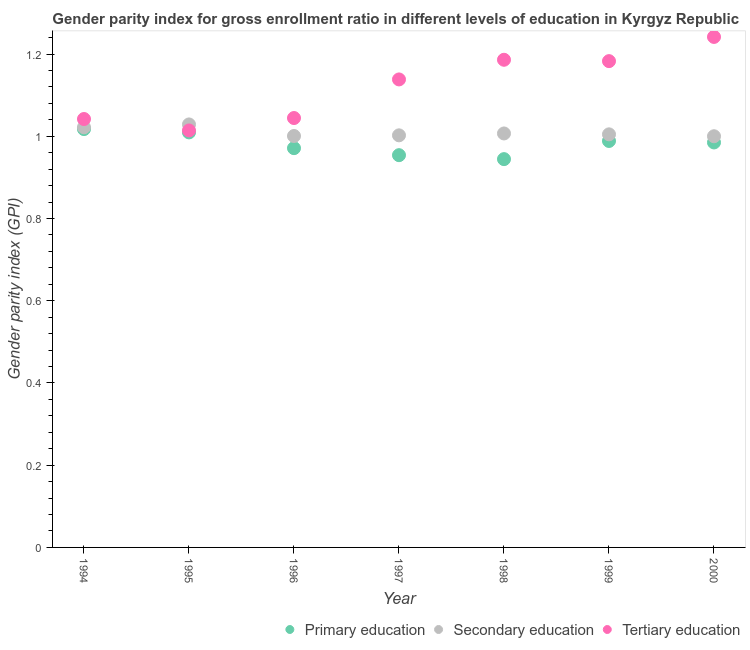How many different coloured dotlines are there?
Your response must be concise. 3. What is the gender parity index in secondary education in 2000?
Provide a succinct answer. 1. Across all years, what is the maximum gender parity index in secondary education?
Your response must be concise. 1.03. Across all years, what is the minimum gender parity index in tertiary education?
Your response must be concise. 1.01. What is the total gender parity index in secondary education in the graph?
Provide a short and direct response. 7.06. What is the difference between the gender parity index in secondary education in 1995 and that in 2000?
Ensure brevity in your answer.  0.03. What is the difference between the gender parity index in primary education in 1997 and the gender parity index in tertiary education in 1995?
Your answer should be very brief. -0.06. What is the average gender parity index in primary education per year?
Give a very brief answer. 0.98. In the year 1997, what is the difference between the gender parity index in primary education and gender parity index in secondary education?
Provide a short and direct response. -0.05. What is the ratio of the gender parity index in primary education in 1994 to that in 1996?
Keep it short and to the point. 1.05. Is the difference between the gender parity index in primary education in 1994 and 1995 greater than the difference between the gender parity index in secondary education in 1994 and 1995?
Your answer should be very brief. Yes. What is the difference between the highest and the second highest gender parity index in tertiary education?
Offer a very short reply. 0.06. What is the difference between the highest and the lowest gender parity index in primary education?
Ensure brevity in your answer.  0.07. In how many years, is the gender parity index in secondary education greater than the average gender parity index in secondary education taken over all years?
Provide a short and direct response. 2. Is the sum of the gender parity index in tertiary education in 1999 and 2000 greater than the maximum gender parity index in primary education across all years?
Your response must be concise. Yes. Is it the case that in every year, the sum of the gender parity index in primary education and gender parity index in secondary education is greater than the gender parity index in tertiary education?
Give a very brief answer. Yes. Is the gender parity index in primary education strictly less than the gender parity index in tertiary education over the years?
Make the answer very short. Yes. How many years are there in the graph?
Provide a short and direct response. 7. What is the difference between two consecutive major ticks on the Y-axis?
Ensure brevity in your answer.  0.2. Does the graph contain grids?
Ensure brevity in your answer.  No. Where does the legend appear in the graph?
Your answer should be compact. Bottom right. What is the title of the graph?
Make the answer very short. Gender parity index for gross enrollment ratio in different levels of education in Kyrgyz Republic. What is the label or title of the X-axis?
Give a very brief answer. Year. What is the label or title of the Y-axis?
Ensure brevity in your answer.  Gender parity index (GPI). What is the Gender parity index (GPI) of Primary education in 1994?
Your answer should be compact. 1.02. What is the Gender parity index (GPI) of Secondary education in 1994?
Ensure brevity in your answer.  1.02. What is the Gender parity index (GPI) in Tertiary education in 1994?
Your answer should be compact. 1.04. What is the Gender parity index (GPI) of Primary education in 1995?
Ensure brevity in your answer.  1.01. What is the Gender parity index (GPI) of Secondary education in 1995?
Ensure brevity in your answer.  1.03. What is the Gender parity index (GPI) of Tertiary education in 1995?
Provide a short and direct response. 1.01. What is the Gender parity index (GPI) in Primary education in 1996?
Offer a terse response. 0.97. What is the Gender parity index (GPI) in Secondary education in 1996?
Your response must be concise. 1. What is the Gender parity index (GPI) in Tertiary education in 1996?
Your response must be concise. 1.04. What is the Gender parity index (GPI) of Primary education in 1997?
Provide a short and direct response. 0.95. What is the Gender parity index (GPI) in Secondary education in 1997?
Your response must be concise. 1. What is the Gender parity index (GPI) of Tertiary education in 1997?
Offer a very short reply. 1.14. What is the Gender parity index (GPI) of Primary education in 1998?
Your response must be concise. 0.94. What is the Gender parity index (GPI) in Secondary education in 1998?
Your response must be concise. 1.01. What is the Gender parity index (GPI) of Tertiary education in 1998?
Provide a short and direct response. 1.19. What is the Gender parity index (GPI) of Primary education in 1999?
Provide a short and direct response. 0.99. What is the Gender parity index (GPI) in Secondary education in 1999?
Give a very brief answer. 1. What is the Gender parity index (GPI) of Tertiary education in 1999?
Your answer should be compact. 1.18. What is the Gender parity index (GPI) in Primary education in 2000?
Keep it short and to the point. 0.98. What is the Gender parity index (GPI) of Secondary education in 2000?
Provide a short and direct response. 1. What is the Gender parity index (GPI) of Tertiary education in 2000?
Your answer should be very brief. 1.24. Across all years, what is the maximum Gender parity index (GPI) of Primary education?
Your answer should be compact. 1.02. Across all years, what is the maximum Gender parity index (GPI) of Secondary education?
Provide a succinct answer. 1.03. Across all years, what is the maximum Gender parity index (GPI) in Tertiary education?
Provide a short and direct response. 1.24. Across all years, what is the minimum Gender parity index (GPI) of Primary education?
Give a very brief answer. 0.94. Across all years, what is the minimum Gender parity index (GPI) in Secondary education?
Provide a succinct answer. 1. Across all years, what is the minimum Gender parity index (GPI) of Tertiary education?
Keep it short and to the point. 1.01. What is the total Gender parity index (GPI) in Primary education in the graph?
Ensure brevity in your answer.  6.87. What is the total Gender parity index (GPI) of Secondary education in the graph?
Offer a very short reply. 7.07. What is the total Gender parity index (GPI) in Tertiary education in the graph?
Your answer should be very brief. 7.85. What is the difference between the Gender parity index (GPI) in Primary education in 1994 and that in 1995?
Provide a short and direct response. 0.01. What is the difference between the Gender parity index (GPI) of Secondary education in 1994 and that in 1995?
Your response must be concise. -0.01. What is the difference between the Gender parity index (GPI) in Tertiary education in 1994 and that in 1995?
Make the answer very short. 0.03. What is the difference between the Gender parity index (GPI) of Primary education in 1994 and that in 1996?
Make the answer very short. 0.05. What is the difference between the Gender parity index (GPI) of Secondary education in 1994 and that in 1996?
Give a very brief answer. 0.02. What is the difference between the Gender parity index (GPI) of Tertiary education in 1994 and that in 1996?
Offer a terse response. -0. What is the difference between the Gender parity index (GPI) in Primary education in 1994 and that in 1997?
Offer a very short reply. 0.06. What is the difference between the Gender parity index (GPI) of Secondary education in 1994 and that in 1997?
Your answer should be compact. 0.02. What is the difference between the Gender parity index (GPI) in Tertiary education in 1994 and that in 1997?
Provide a succinct answer. -0.1. What is the difference between the Gender parity index (GPI) of Primary education in 1994 and that in 1998?
Offer a terse response. 0.07. What is the difference between the Gender parity index (GPI) of Secondary education in 1994 and that in 1998?
Provide a succinct answer. 0.01. What is the difference between the Gender parity index (GPI) in Tertiary education in 1994 and that in 1998?
Provide a short and direct response. -0.14. What is the difference between the Gender parity index (GPI) in Primary education in 1994 and that in 1999?
Provide a short and direct response. 0.03. What is the difference between the Gender parity index (GPI) of Secondary education in 1994 and that in 1999?
Your answer should be compact. 0.02. What is the difference between the Gender parity index (GPI) of Tertiary education in 1994 and that in 1999?
Offer a very short reply. -0.14. What is the difference between the Gender parity index (GPI) in Primary education in 1994 and that in 2000?
Your response must be concise. 0.03. What is the difference between the Gender parity index (GPI) in Secondary education in 1994 and that in 2000?
Your response must be concise. 0.02. What is the difference between the Gender parity index (GPI) of Tertiary education in 1994 and that in 2000?
Make the answer very short. -0.2. What is the difference between the Gender parity index (GPI) of Primary education in 1995 and that in 1996?
Provide a short and direct response. 0.04. What is the difference between the Gender parity index (GPI) of Secondary education in 1995 and that in 1996?
Keep it short and to the point. 0.03. What is the difference between the Gender parity index (GPI) of Tertiary education in 1995 and that in 1996?
Offer a terse response. -0.03. What is the difference between the Gender parity index (GPI) of Primary education in 1995 and that in 1997?
Your answer should be very brief. 0.06. What is the difference between the Gender parity index (GPI) of Secondary education in 1995 and that in 1997?
Ensure brevity in your answer.  0.03. What is the difference between the Gender parity index (GPI) of Tertiary education in 1995 and that in 1997?
Keep it short and to the point. -0.12. What is the difference between the Gender parity index (GPI) of Primary education in 1995 and that in 1998?
Give a very brief answer. 0.07. What is the difference between the Gender parity index (GPI) of Secondary education in 1995 and that in 1998?
Your answer should be compact. 0.02. What is the difference between the Gender parity index (GPI) of Tertiary education in 1995 and that in 1998?
Offer a very short reply. -0.17. What is the difference between the Gender parity index (GPI) in Primary education in 1995 and that in 1999?
Provide a succinct answer. 0.02. What is the difference between the Gender parity index (GPI) in Secondary education in 1995 and that in 1999?
Your response must be concise. 0.02. What is the difference between the Gender parity index (GPI) of Tertiary education in 1995 and that in 1999?
Your answer should be compact. -0.17. What is the difference between the Gender parity index (GPI) in Primary education in 1995 and that in 2000?
Provide a succinct answer. 0.02. What is the difference between the Gender parity index (GPI) of Secondary education in 1995 and that in 2000?
Provide a short and direct response. 0.03. What is the difference between the Gender parity index (GPI) of Tertiary education in 1995 and that in 2000?
Make the answer very short. -0.23. What is the difference between the Gender parity index (GPI) of Primary education in 1996 and that in 1997?
Ensure brevity in your answer.  0.02. What is the difference between the Gender parity index (GPI) in Secondary education in 1996 and that in 1997?
Keep it short and to the point. -0. What is the difference between the Gender parity index (GPI) in Tertiary education in 1996 and that in 1997?
Offer a terse response. -0.09. What is the difference between the Gender parity index (GPI) in Primary education in 1996 and that in 1998?
Provide a succinct answer. 0.03. What is the difference between the Gender parity index (GPI) in Secondary education in 1996 and that in 1998?
Provide a short and direct response. -0.01. What is the difference between the Gender parity index (GPI) in Tertiary education in 1996 and that in 1998?
Your answer should be compact. -0.14. What is the difference between the Gender parity index (GPI) of Primary education in 1996 and that in 1999?
Keep it short and to the point. -0.02. What is the difference between the Gender parity index (GPI) of Secondary education in 1996 and that in 1999?
Give a very brief answer. -0. What is the difference between the Gender parity index (GPI) in Tertiary education in 1996 and that in 1999?
Keep it short and to the point. -0.14. What is the difference between the Gender parity index (GPI) in Primary education in 1996 and that in 2000?
Give a very brief answer. -0.01. What is the difference between the Gender parity index (GPI) of Secondary education in 1996 and that in 2000?
Your answer should be very brief. 0. What is the difference between the Gender parity index (GPI) in Tertiary education in 1996 and that in 2000?
Make the answer very short. -0.2. What is the difference between the Gender parity index (GPI) of Primary education in 1997 and that in 1998?
Provide a succinct answer. 0.01. What is the difference between the Gender parity index (GPI) of Secondary education in 1997 and that in 1998?
Your answer should be compact. -0. What is the difference between the Gender parity index (GPI) in Tertiary education in 1997 and that in 1998?
Make the answer very short. -0.05. What is the difference between the Gender parity index (GPI) of Primary education in 1997 and that in 1999?
Your answer should be compact. -0.03. What is the difference between the Gender parity index (GPI) in Secondary education in 1997 and that in 1999?
Offer a very short reply. -0. What is the difference between the Gender parity index (GPI) in Tertiary education in 1997 and that in 1999?
Offer a terse response. -0.04. What is the difference between the Gender parity index (GPI) of Primary education in 1997 and that in 2000?
Your response must be concise. -0.03. What is the difference between the Gender parity index (GPI) of Secondary education in 1997 and that in 2000?
Make the answer very short. 0. What is the difference between the Gender parity index (GPI) of Tertiary education in 1997 and that in 2000?
Offer a terse response. -0.1. What is the difference between the Gender parity index (GPI) in Primary education in 1998 and that in 1999?
Ensure brevity in your answer.  -0.04. What is the difference between the Gender parity index (GPI) in Secondary education in 1998 and that in 1999?
Provide a succinct answer. 0. What is the difference between the Gender parity index (GPI) of Tertiary education in 1998 and that in 1999?
Provide a succinct answer. 0. What is the difference between the Gender parity index (GPI) of Primary education in 1998 and that in 2000?
Keep it short and to the point. -0.04. What is the difference between the Gender parity index (GPI) of Secondary education in 1998 and that in 2000?
Your response must be concise. 0.01. What is the difference between the Gender parity index (GPI) in Tertiary education in 1998 and that in 2000?
Keep it short and to the point. -0.06. What is the difference between the Gender parity index (GPI) in Primary education in 1999 and that in 2000?
Provide a short and direct response. 0. What is the difference between the Gender parity index (GPI) of Secondary education in 1999 and that in 2000?
Your response must be concise. 0. What is the difference between the Gender parity index (GPI) in Tertiary education in 1999 and that in 2000?
Your response must be concise. -0.06. What is the difference between the Gender parity index (GPI) of Primary education in 1994 and the Gender parity index (GPI) of Secondary education in 1995?
Give a very brief answer. -0.01. What is the difference between the Gender parity index (GPI) in Primary education in 1994 and the Gender parity index (GPI) in Tertiary education in 1995?
Make the answer very short. 0. What is the difference between the Gender parity index (GPI) of Secondary education in 1994 and the Gender parity index (GPI) of Tertiary education in 1995?
Give a very brief answer. 0.01. What is the difference between the Gender parity index (GPI) in Primary education in 1994 and the Gender parity index (GPI) in Secondary education in 1996?
Provide a short and direct response. 0.02. What is the difference between the Gender parity index (GPI) in Primary education in 1994 and the Gender parity index (GPI) in Tertiary education in 1996?
Your response must be concise. -0.03. What is the difference between the Gender parity index (GPI) in Secondary education in 1994 and the Gender parity index (GPI) in Tertiary education in 1996?
Your answer should be very brief. -0.02. What is the difference between the Gender parity index (GPI) in Primary education in 1994 and the Gender parity index (GPI) in Secondary education in 1997?
Offer a very short reply. 0.02. What is the difference between the Gender parity index (GPI) of Primary education in 1994 and the Gender parity index (GPI) of Tertiary education in 1997?
Your answer should be compact. -0.12. What is the difference between the Gender parity index (GPI) in Secondary education in 1994 and the Gender parity index (GPI) in Tertiary education in 1997?
Offer a very short reply. -0.12. What is the difference between the Gender parity index (GPI) in Primary education in 1994 and the Gender parity index (GPI) in Secondary education in 1998?
Make the answer very short. 0.01. What is the difference between the Gender parity index (GPI) in Primary education in 1994 and the Gender parity index (GPI) in Tertiary education in 1998?
Give a very brief answer. -0.17. What is the difference between the Gender parity index (GPI) of Secondary education in 1994 and the Gender parity index (GPI) of Tertiary education in 1998?
Ensure brevity in your answer.  -0.16. What is the difference between the Gender parity index (GPI) of Primary education in 1994 and the Gender parity index (GPI) of Secondary education in 1999?
Your answer should be compact. 0.01. What is the difference between the Gender parity index (GPI) in Primary education in 1994 and the Gender parity index (GPI) in Tertiary education in 1999?
Make the answer very short. -0.17. What is the difference between the Gender parity index (GPI) of Secondary education in 1994 and the Gender parity index (GPI) of Tertiary education in 1999?
Provide a succinct answer. -0.16. What is the difference between the Gender parity index (GPI) of Primary education in 1994 and the Gender parity index (GPI) of Secondary education in 2000?
Offer a very short reply. 0.02. What is the difference between the Gender parity index (GPI) of Primary education in 1994 and the Gender parity index (GPI) of Tertiary education in 2000?
Provide a short and direct response. -0.22. What is the difference between the Gender parity index (GPI) of Secondary education in 1994 and the Gender parity index (GPI) of Tertiary education in 2000?
Provide a short and direct response. -0.22. What is the difference between the Gender parity index (GPI) of Primary education in 1995 and the Gender parity index (GPI) of Secondary education in 1996?
Your answer should be compact. 0.01. What is the difference between the Gender parity index (GPI) in Primary education in 1995 and the Gender parity index (GPI) in Tertiary education in 1996?
Make the answer very short. -0.03. What is the difference between the Gender parity index (GPI) in Secondary education in 1995 and the Gender parity index (GPI) in Tertiary education in 1996?
Offer a very short reply. -0.02. What is the difference between the Gender parity index (GPI) in Primary education in 1995 and the Gender parity index (GPI) in Secondary education in 1997?
Your response must be concise. 0.01. What is the difference between the Gender parity index (GPI) of Primary education in 1995 and the Gender parity index (GPI) of Tertiary education in 1997?
Offer a very short reply. -0.13. What is the difference between the Gender parity index (GPI) of Secondary education in 1995 and the Gender parity index (GPI) of Tertiary education in 1997?
Make the answer very short. -0.11. What is the difference between the Gender parity index (GPI) in Primary education in 1995 and the Gender parity index (GPI) in Secondary education in 1998?
Provide a succinct answer. 0. What is the difference between the Gender parity index (GPI) of Primary education in 1995 and the Gender parity index (GPI) of Tertiary education in 1998?
Offer a very short reply. -0.18. What is the difference between the Gender parity index (GPI) in Secondary education in 1995 and the Gender parity index (GPI) in Tertiary education in 1998?
Your answer should be compact. -0.16. What is the difference between the Gender parity index (GPI) of Primary education in 1995 and the Gender parity index (GPI) of Secondary education in 1999?
Give a very brief answer. 0. What is the difference between the Gender parity index (GPI) of Primary education in 1995 and the Gender parity index (GPI) of Tertiary education in 1999?
Ensure brevity in your answer.  -0.17. What is the difference between the Gender parity index (GPI) in Secondary education in 1995 and the Gender parity index (GPI) in Tertiary education in 1999?
Your response must be concise. -0.15. What is the difference between the Gender parity index (GPI) in Primary education in 1995 and the Gender parity index (GPI) in Secondary education in 2000?
Provide a succinct answer. 0.01. What is the difference between the Gender parity index (GPI) of Primary education in 1995 and the Gender parity index (GPI) of Tertiary education in 2000?
Offer a very short reply. -0.23. What is the difference between the Gender parity index (GPI) in Secondary education in 1995 and the Gender parity index (GPI) in Tertiary education in 2000?
Your answer should be very brief. -0.21. What is the difference between the Gender parity index (GPI) in Primary education in 1996 and the Gender parity index (GPI) in Secondary education in 1997?
Keep it short and to the point. -0.03. What is the difference between the Gender parity index (GPI) of Primary education in 1996 and the Gender parity index (GPI) of Tertiary education in 1997?
Give a very brief answer. -0.17. What is the difference between the Gender parity index (GPI) of Secondary education in 1996 and the Gender parity index (GPI) of Tertiary education in 1997?
Your answer should be compact. -0.14. What is the difference between the Gender parity index (GPI) in Primary education in 1996 and the Gender parity index (GPI) in Secondary education in 1998?
Your answer should be compact. -0.04. What is the difference between the Gender parity index (GPI) in Primary education in 1996 and the Gender parity index (GPI) in Tertiary education in 1998?
Give a very brief answer. -0.21. What is the difference between the Gender parity index (GPI) of Secondary education in 1996 and the Gender parity index (GPI) of Tertiary education in 1998?
Make the answer very short. -0.19. What is the difference between the Gender parity index (GPI) in Primary education in 1996 and the Gender parity index (GPI) in Secondary education in 1999?
Keep it short and to the point. -0.03. What is the difference between the Gender parity index (GPI) in Primary education in 1996 and the Gender parity index (GPI) in Tertiary education in 1999?
Keep it short and to the point. -0.21. What is the difference between the Gender parity index (GPI) in Secondary education in 1996 and the Gender parity index (GPI) in Tertiary education in 1999?
Your response must be concise. -0.18. What is the difference between the Gender parity index (GPI) of Primary education in 1996 and the Gender parity index (GPI) of Secondary education in 2000?
Your answer should be compact. -0.03. What is the difference between the Gender parity index (GPI) of Primary education in 1996 and the Gender parity index (GPI) of Tertiary education in 2000?
Give a very brief answer. -0.27. What is the difference between the Gender parity index (GPI) in Secondary education in 1996 and the Gender parity index (GPI) in Tertiary education in 2000?
Your answer should be compact. -0.24. What is the difference between the Gender parity index (GPI) in Primary education in 1997 and the Gender parity index (GPI) in Secondary education in 1998?
Your answer should be very brief. -0.05. What is the difference between the Gender parity index (GPI) in Primary education in 1997 and the Gender parity index (GPI) in Tertiary education in 1998?
Offer a very short reply. -0.23. What is the difference between the Gender parity index (GPI) of Secondary education in 1997 and the Gender parity index (GPI) of Tertiary education in 1998?
Give a very brief answer. -0.18. What is the difference between the Gender parity index (GPI) in Primary education in 1997 and the Gender parity index (GPI) in Secondary education in 1999?
Provide a succinct answer. -0.05. What is the difference between the Gender parity index (GPI) in Primary education in 1997 and the Gender parity index (GPI) in Tertiary education in 1999?
Your answer should be compact. -0.23. What is the difference between the Gender parity index (GPI) of Secondary education in 1997 and the Gender parity index (GPI) of Tertiary education in 1999?
Offer a very short reply. -0.18. What is the difference between the Gender parity index (GPI) in Primary education in 1997 and the Gender parity index (GPI) in Secondary education in 2000?
Ensure brevity in your answer.  -0.05. What is the difference between the Gender parity index (GPI) of Primary education in 1997 and the Gender parity index (GPI) of Tertiary education in 2000?
Provide a short and direct response. -0.29. What is the difference between the Gender parity index (GPI) of Secondary education in 1997 and the Gender parity index (GPI) of Tertiary education in 2000?
Ensure brevity in your answer.  -0.24. What is the difference between the Gender parity index (GPI) of Primary education in 1998 and the Gender parity index (GPI) of Secondary education in 1999?
Make the answer very short. -0.06. What is the difference between the Gender parity index (GPI) in Primary education in 1998 and the Gender parity index (GPI) in Tertiary education in 1999?
Your answer should be compact. -0.24. What is the difference between the Gender parity index (GPI) in Secondary education in 1998 and the Gender parity index (GPI) in Tertiary education in 1999?
Make the answer very short. -0.18. What is the difference between the Gender parity index (GPI) of Primary education in 1998 and the Gender parity index (GPI) of Secondary education in 2000?
Provide a short and direct response. -0.06. What is the difference between the Gender parity index (GPI) in Primary education in 1998 and the Gender parity index (GPI) in Tertiary education in 2000?
Offer a terse response. -0.3. What is the difference between the Gender parity index (GPI) in Secondary education in 1998 and the Gender parity index (GPI) in Tertiary education in 2000?
Your answer should be very brief. -0.23. What is the difference between the Gender parity index (GPI) in Primary education in 1999 and the Gender parity index (GPI) in Secondary education in 2000?
Provide a short and direct response. -0.01. What is the difference between the Gender parity index (GPI) of Primary education in 1999 and the Gender parity index (GPI) of Tertiary education in 2000?
Ensure brevity in your answer.  -0.25. What is the difference between the Gender parity index (GPI) of Secondary education in 1999 and the Gender parity index (GPI) of Tertiary education in 2000?
Provide a succinct answer. -0.24. What is the average Gender parity index (GPI) of Primary education per year?
Offer a very short reply. 0.98. What is the average Gender parity index (GPI) of Secondary education per year?
Offer a terse response. 1.01. What is the average Gender parity index (GPI) in Tertiary education per year?
Give a very brief answer. 1.12. In the year 1994, what is the difference between the Gender parity index (GPI) in Primary education and Gender parity index (GPI) in Secondary education?
Your answer should be very brief. -0. In the year 1994, what is the difference between the Gender parity index (GPI) of Primary education and Gender parity index (GPI) of Tertiary education?
Your answer should be compact. -0.02. In the year 1994, what is the difference between the Gender parity index (GPI) in Secondary education and Gender parity index (GPI) in Tertiary education?
Provide a short and direct response. -0.02. In the year 1995, what is the difference between the Gender parity index (GPI) of Primary education and Gender parity index (GPI) of Secondary education?
Provide a succinct answer. -0.02. In the year 1995, what is the difference between the Gender parity index (GPI) in Primary education and Gender parity index (GPI) in Tertiary education?
Your answer should be very brief. -0. In the year 1995, what is the difference between the Gender parity index (GPI) of Secondary education and Gender parity index (GPI) of Tertiary education?
Ensure brevity in your answer.  0.01. In the year 1996, what is the difference between the Gender parity index (GPI) of Primary education and Gender parity index (GPI) of Secondary education?
Your response must be concise. -0.03. In the year 1996, what is the difference between the Gender parity index (GPI) in Primary education and Gender parity index (GPI) in Tertiary education?
Your response must be concise. -0.07. In the year 1996, what is the difference between the Gender parity index (GPI) in Secondary education and Gender parity index (GPI) in Tertiary education?
Your answer should be very brief. -0.04. In the year 1997, what is the difference between the Gender parity index (GPI) of Primary education and Gender parity index (GPI) of Secondary education?
Provide a succinct answer. -0.05. In the year 1997, what is the difference between the Gender parity index (GPI) in Primary education and Gender parity index (GPI) in Tertiary education?
Give a very brief answer. -0.18. In the year 1997, what is the difference between the Gender parity index (GPI) of Secondary education and Gender parity index (GPI) of Tertiary education?
Offer a very short reply. -0.14. In the year 1998, what is the difference between the Gender parity index (GPI) of Primary education and Gender parity index (GPI) of Secondary education?
Your answer should be compact. -0.06. In the year 1998, what is the difference between the Gender parity index (GPI) of Primary education and Gender parity index (GPI) of Tertiary education?
Provide a succinct answer. -0.24. In the year 1998, what is the difference between the Gender parity index (GPI) in Secondary education and Gender parity index (GPI) in Tertiary education?
Make the answer very short. -0.18. In the year 1999, what is the difference between the Gender parity index (GPI) of Primary education and Gender parity index (GPI) of Secondary education?
Provide a short and direct response. -0.02. In the year 1999, what is the difference between the Gender parity index (GPI) of Primary education and Gender parity index (GPI) of Tertiary education?
Offer a terse response. -0.19. In the year 1999, what is the difference between the Gender parity index (GPI) in Secondary education and Gender parity index (GPI) in Tertiary education?
Provide a succinct answer. -0.18. In the year 2000, what is the difference between the Gender parity index (GPI) of Primary education and Gender parity index (GPI) of Secondary education?
Make the answer very short. -0.02. In the year 2000, what is the difference between the Gender parity index (GPI) in Primary education and Gender parity index (GPI) in Tertiary education?
Offer a very short reply. -0.26. In the year 2000, what is the difference between the Gender parity index (GPI) of Secondary education and Gender parity index (GPI) of Tertiary education?
Your answer should be compact. -0.24. What is the ratio of the Gender parity index (GPI) in Primary education in 1994 to that in 1995?
Ensure brevity in your answer.  1.01. What is the ratio of the Gender parity index (GPI) in Tertiary education in 1994 to that in 1995?
Give a very brief answer. 1.03. What is the ratio of the Gender parity index (GPI) in Primary education in 1994 to that in 1996?
Provide a succinct answer. 1.05. What is the ratio of the Gender parity index (GPI) of Secondary education in 1994 to that in 1996?
Your answer should be compact. 1.02. What is the ratio of the Gender parity index (GPI) of Tertiary education in 1994 to that in 1996?
Offer a terse response. 1. What is the ratio of the Gender parity index (GPI) of Primary education in 1994 to that in 1997?
Your response must be concise. 1.07. What is the ratio of the Gender parity index (GPI) of Secondary education in 1994 to that in 1997?
Offer a terse response. 1.02. What is the ratio of the Gender parity index (GPI) of Tertiary education in 1994 to that in 1997?
Your response must be concise. 0.92. What is the ratio of the Gender parity index (GPI) in Primary education in 1994 to that in 1998?
Make the answer very short. 1.08. What is the ratio of the Gender parity index (GPI) of Secondary education in 1994 to that in 1998?
Provide a short and direct response. 1.01. What is the ratio of the Gender parity index (GPI) in Tertiary education in 1994 to that in 1998?
Keep it short and to the point. 0.88. What is the ratio of the Gender parity index (GPI) of Primary education in 1994 to that in 1999?
Ensure brevity in your answer.  1.03. What is the ratio of the Gender parity index (GPI) of Secondary education in 1994 to that in 1999?
Your answer should be very brief. 1.02. What is the ratio of the Gender parity index (GPI) in Tertiary education in 1994 to that in 1999?
Your answer should be compact. 0.88. What is the ratio of the Gender parity index (GPI) in Primary education in 1994 to that in 2000?
Provide a succinct answer. 1.03. What is the ratio of the Gender parity index (GPI) in Secondary education in 1994 to that in 2000?
Your answer should be very brief. 1.02. What is the ratio of the Gender parity index (GPI) of Tertiary education in 1994 to that in 2000?
Offer a terse response. 0.84. What is the ratio of the Gender parity index (GPI) of Primary education in 1995 to that in 1996?
Ensure brevity in your answer.  1.04. What is the ratio of the Gender parity index (GPI) in Secondary education in 1995 to that in 1996?
Offer a terse response. 1.03. What is the ratio of the Gender parity index (GPI) in Tertiary education in 1995 to that in 1996?
Keep it short and to the point. 0.97. What is the ratio of the Gender parity index (GPI) in Primary education in 1995 to that in 1997?
Ensure brevity in your answer.  1.06. What is the ratio of the Gender parity index (GPI) in Secondary education in 1995 to that in 1997?
Offer a terse response. 1.03. What is the ratio of the Gender parity index (GPI) in Tertiary education in 1995 to that in 1997?
Ensure brevity in your answer.  0.89. What is the ratio of the Gender parity index (GPI) in Primary education in 1995 to that in 1998?
Keep it short and to the point. 1.07. What is the ratio of the Gender parity index (GPI) in Secondary education in 1995 to that in 1998?
Provide a short and direct response. 1.02. What is the ratio of the Gender parity index (GPI) of Tertiary education in 1995 to that in 1998?
Your answer should be very brief. 0.86. What is the ratio of the Gender parity index (GPI) of Primary education in 1995 to that in 1999?
Give a very brief answer. 1.02. What is the ratio of the Gender parity index (GPI) in Tertiary education in 1995 to that in 1999?
Offer a terse response. 0.86. What is the ratio of the Gender parity index (GPI) in Primary education in 1995 to that in 2000?
Ensure brevity in your answer.  1.02. What is the ratio of the Gender parity index (GPI) of Secondary education in 1995 to that in 2000?
Give a very brief answer. 1.03. What is the ratio of the Gender parity index (GPI) of Tertiary education in 1995 to that in 2000?
Your response must be concise. 0.82. What is the ratio of the Gender parity index (GPI) of Primary education in 1996 to that in 1997?
Ensure brevity in your answer.  1.02. What is the ratio of the Gender parity index (GPI) in Tertiary education in 1996 to that in 1997?
Provide a succinct answer. 0.92. What is the ratio of the Gender parity index (GPI) of Primary education in 1996 to that in 1998?
Give a very brief answer. 1.03. What is the ratio of the Gender parity index (GPI) in Tertiary education in 1996 to that in 1998?
Offer a very short reply. 0.88. What is the ratio of the Gender parity index (GPI) in Primary education in 1996 to that in 1999?
Offer a very short reply. 0.98. What is the ratio of the Gender parity index (GPI) in Tertiary education in 1996 to that in 1999?
Ensure brevity in your answer.  0.88. What is the ratio of the Gender parity index (GPI) of Primary education in 1996 to that in 2000?
Keep it short and to the point. 0.99. What is the ratio of the Gender parity index (GPI) in Tertiary education in 1996 to that in 2000?
Ensure brevity in your answer.  0.84. What is the ratio of the Gender parity index (GPI) of Primary education in 1997 to that in 1998?
Provide a succinct answer. 1.01. What is the ratio of the Gender parity index (GPI) of Secondary education in 1997 to that in 1998?
Offer a very short reply. 1. What is the ratio of the Gender parity index (GPI) of Tertiary education in 1997 to that in 1998?
Offer a very short reply. 0.96. What is the ratio of the Gender parity index (GPI) of Primary education in 1997 to that in 1999?
Your response must be concise. 0.96. What is the ratio of the Gender parity index (GPI) in Secondary education in 1997 to that in 1999?
Keep it short and to the point. 1. What is the ratio of the Gender parity index (GPI) of Tertiary education in 1997 to that in 1999?
Offer a terse response. 0.96. What is the ratio of the Gender parity index (GPI) of Primary education in 1997 to that in 2000?
Ensure brevity in your answer.  0.97. What is the ratio of the Gender parity index (GPI) of Tertiary education in 1997 to that in 2000?
Offer a terse response. 0.92. What is the ratio of the Gender parity index (GPI) in Primary education in 1998 to that in 1999?
Your response must be concise. 0.96. What is the ratio of the Gender parity index (GPI) in Secondary education in 1998 to that in 1999?
Keep it short and to the point. 1. What is the ratio of the Gender parity index (GPI) of Tertiary education in 1998 to that in 1999?
Provide a short and direct response. 1. What is the ratio of the Gender parity index (GPI) of Primary education in 1998 to that in 2000?
Your answer should be compact. 0.96. What is the ratio of the Gender parity index (GPI) in Secondary education in 1998 to that in 2000?
Offer a very short reply. 1.01. What is the ratio of the Gender parity index (GPI) in Tertiary education in 1998 to that in 2000?
Offer a terse response. 0.96. What is the ratio of the Gender parity index (GPI) in Secondary education in 1999 to that in 2000?
Your response must be concise. 1. What is the ratio of the Gender parity index (GPI) in Tertiary education in 1999 to that in 2000?
Ensure brevity in your answer.  0.95. What is the difference between the highest and the second highest Gender parity index (GPI) of Primary education?
Keep it short and to the point. 0.01. What is the difference between the highest and the second highest Gender parity index (GPI) in Secondary education?
Your answer should be compact. 0.01. What is the difference between the highest and the second highest Gender parity index (GPI) of Tertiary education?
Your answer should be very brief. 0.06. What is the difference between the highest and the lowest Gender parity index (GPI) of Primary education?
Keep it short and to the point. 0.07. What is the difference between the highest and the lowest Gender parity index (GPI) of Secondary education?
Keep it short and to the point. 0.03. What is the difference between the highest and the lowest Gender parity index (GPI) of Tertiary education?
Make the answer very short. 0.23. 